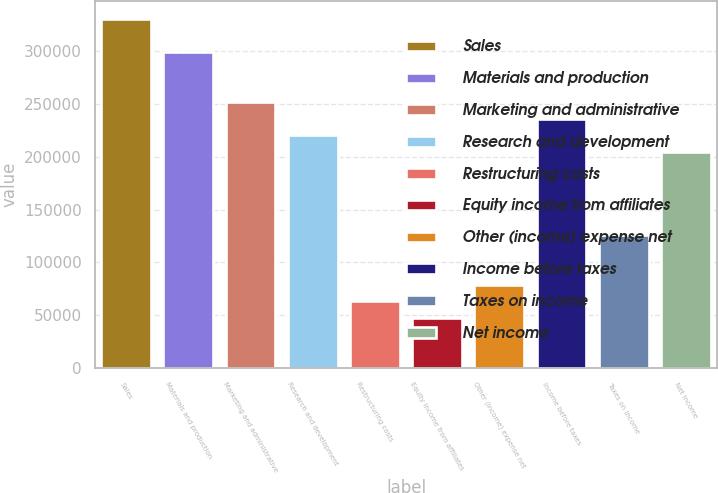Convert chart to OTSL. <chart><loc_0><loc_0><loc_500><loc_500><bar_chart><fcel>Sales<fcel>Materials and production<fcel>Marketing and administrative<fcel>Research and development<fcel>Restructuring costs<fcel>Equity income from affiliates<fcel>Other (income) expense net<fcel>Income before taxes<fcel>Taxes on income<fcel>Net income<nl><fcel>330538<fcel>299058<fcel>251839<fcel>220359<fcel>62961.2<fcel>47221.4<fcel>78701<fcel>236099<fcel>125920<fcel>204619<nl></chart> 